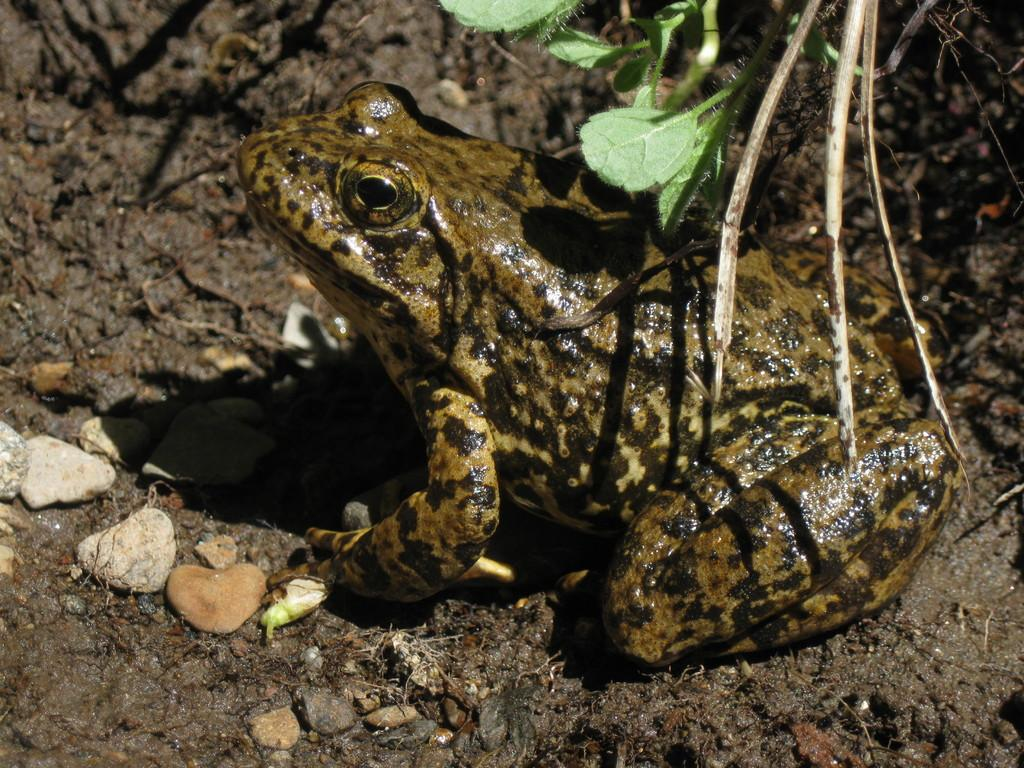What animal is present in the picture? There is a frog in the picture. Where is the frog located? The frog is on the ground. What other objects can be seen in the picture? There are stones and leaves in the picture. Who is the frog talking to in the picture? The frog is not talking to anyone in the picture, as it is an animal and cannot engage in conversation. 